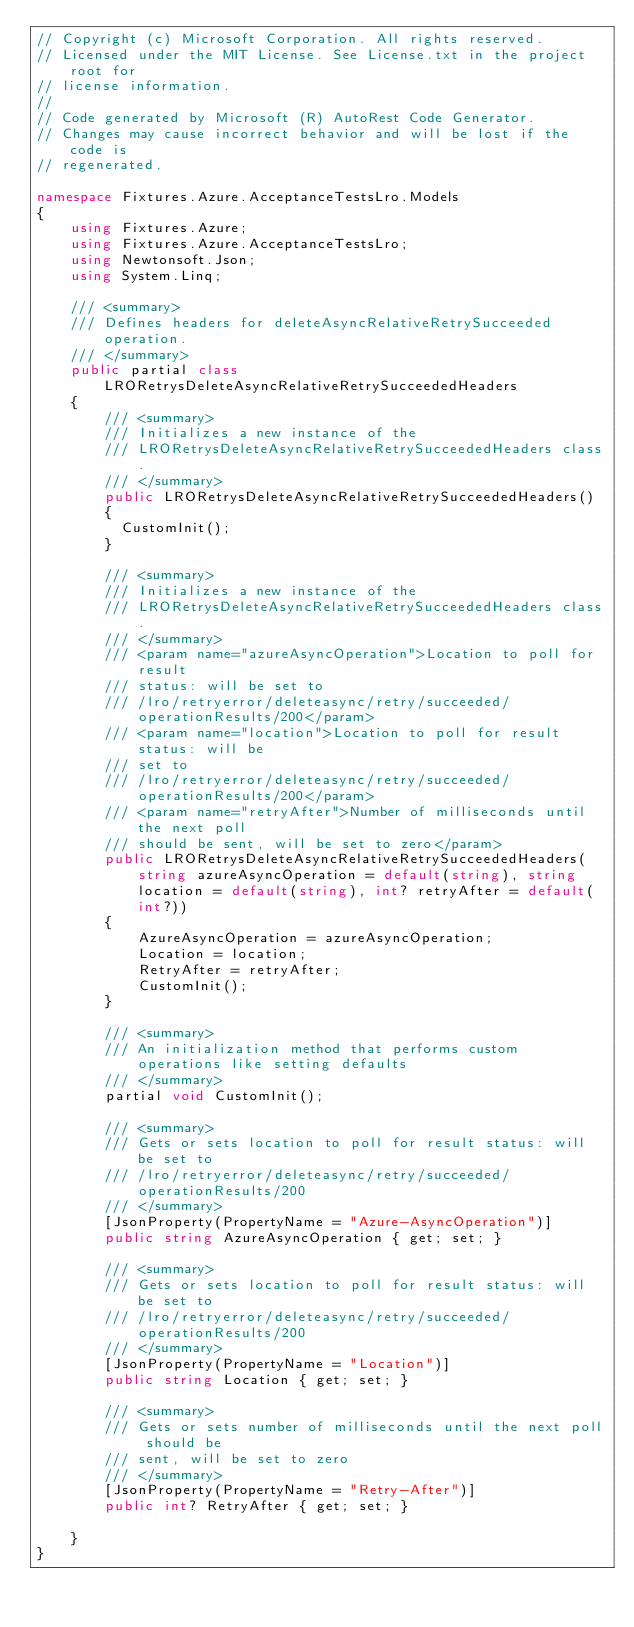Convert code to text. <code><loc_0><loc_0><loc_500><loc_500><_C#_>// Copyright (c) Microsoft Corporation. All rights reserved.
// Licensed under the MIT License. See License.txt in the project root for
// license information.
//
// Code generated by Microsoft (R) AutoRest Code Generator.
// Changes may cause incorrect behavior and will be lost if the code is
// regenerated.

namespace Fixtures.Azure.AcceptanceTestsLro.Models
{
    using Fixtures.Azure;
    using Fixtures.Azure.AcceptanceTestsLro;
    using Newtonsoft.Json;
    using System.Linq;

    /// <summary>
    /// Defines headers for deleteAsyncRelativeRetrySucceeded operation.
    /// </summary>
    public partial class LRORetrysDeleteAsyncRelativeRetrySucceededHeaders
    {
        /// <summary>
        /// Initializes a new instance of the
        /// LRORetrysDeleteAsyncRelativeRetrySucceededHeaders class.
        /// </summary>
        public LRORetrysDeleteAsyncRelativeRetrySucceededHeaders()
        {
          CustomInit();
        }

        /// <summary>
        /// Initializes a new instance of the
        /// LRORetrysDeleteAsyncRelativeRetrySucceededHeaders class.
        /// </summary>
        /// <param name="azureAsyncOperation">Location to poll for result
        /// status: will be set to
        /// /lro/retryerror/deleteasync/retry/succeeded/operationResults/200</param>
        /// <param name="location">Location to poll for result status: will be
        /// set to
        /// /lro/retryerror/deleteasync/retry/succeeded/operationResults/200</param>
        /// <param name="retryAfter">Number of milliseconds until the next poll
        /// should be sent, will be set to zero</param>
        public LRORetrysDeleteAsyncRelativeRetrySucceededHeaders(string azureAsyncOperation = default(string), string location = default(string), int? retryAfter = default(int?))
        {
            AzureAsyncOperation = azureAsyncOperation;
            Location = location;
            RetryAfter = retryAfter;
            CustomInit();
        }

        /// <summary>
        /// An initialization method that performs custom operations like setting defaults
        /// </summary>
        partial void CustomInit();

        /// <summary>
        /// Gets or sets location to poll for result status: will be set to
        /// /lro/retryerror/deleteasync/retry/succeeded/operationResults/200
        /// </summary>
        [JsonProperty(PropertyName = "Azure-AsyncOperation")]
        public string AzureAsyncOperation { get; set; }

        /// <summary>
        /// Gets or sets location to poll for result status: will be set to
        /// /lro/retryerror/deleteasync/retry/succeeded/operationResults/200
        /// </summary>
        [JsonProperty(PropertyName = "Location")]
        public string Location { get; set; }

        /// <summary>
        /// Gets or sets number of milliseconds until the next poll should be
        /// sent, will be set to zero
        /// </summary>
        [JsonProperty(PropertyName = "Retry-After")]
        public int? RetryAfter { get; set; }

    }
}
</code> 